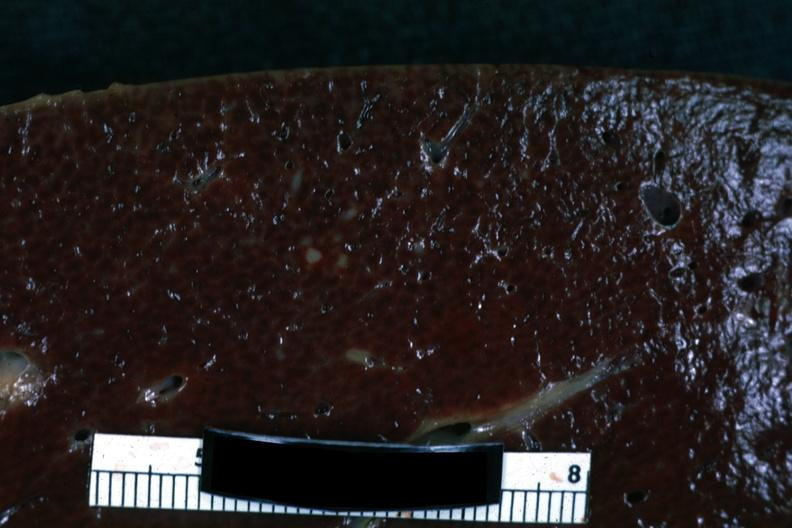s hematologic present?
Answer the question using a single word or phrase. Yes 